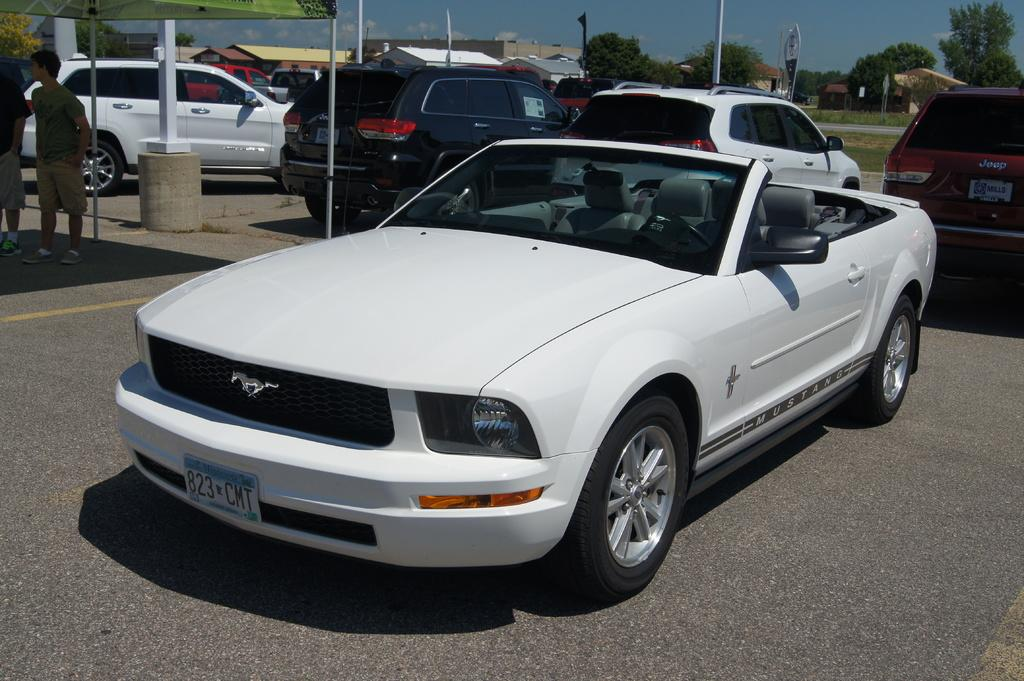What can be seen on the road in the image? There are vehicles on the road in the image. How many people are standing in the image? There are two persons standing in the image. What type of structures are visible in the image? There are buildings in the image. What other natural elements can be seen in the image? There are trees in the image. What object is being used by one of the persons in the image? There is an umbrella in the image. What is visible in the background of the image? The sky is visible in the background of the image. How much dust can be seen on the vehicles in the image? There is no information about dust on the vehicles in the image, so it cannot be determined. What type of material is used to cover the trees in the image? There is no material used to cover the trees in the image; they are visible as they are. 